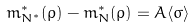Convert formula to latex. <formula><loc_0><loc_0><loc_500><loc_500>m ^ { * } _ { N ^ { * } } ( \rho ) - m ^ { * } _ { N } ( \rho ) = A \langle \sigma \rangle</formula> 